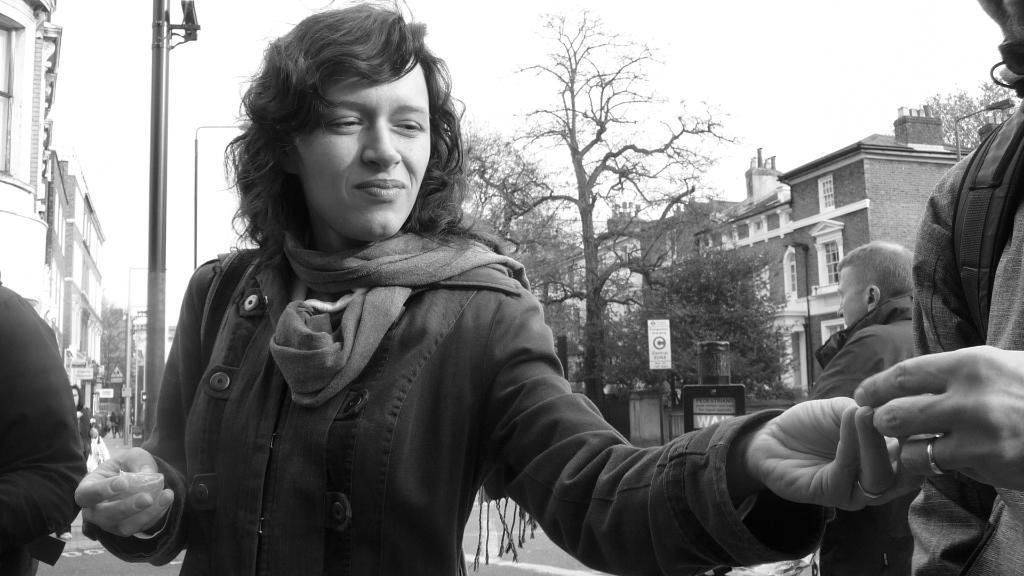Who is the main subject in the image? There is a lady in the image. What is the lady holding in the image? The lady is holding an object. Can you describe the people visible behind the lady? There are people visible behind the lady. What can be seen in the background of the image? There are trees, buildings, an electrical pole, and the sky visible in the background of the image. What type of owl can be seen perched on the lady's shoulder in the image? There is no owl present in the image; the lady is holding an object, but it is not an owl. Can you tell me how many snakes are wrapped around the lady's legs in the image? There are no snakes present in the image; the lady is simply holding an object. 